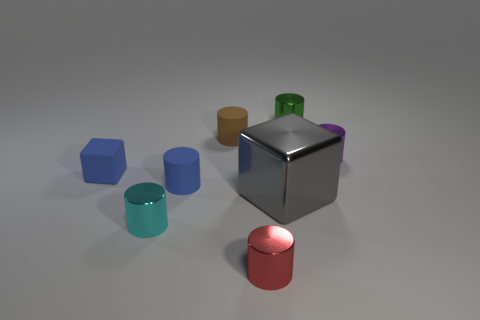Subtract all small brown rubber cylinders. How many cylinders are left? 5 Add 1 small cyan objects. How many objects exist? 9 Subtract all gray cubes. How many cubes are left? 1 Subtract 1 cubes. How many cubes are left? 1 Subtract 1 cyan cylinders. How many objects are left? 7 Subtract all cylinders. How many objects are left? 2 Subtract all yellow cylinders. Subtract all yellow cubes. How many cylinders are left? 6 Subtract all cyan balls. How many green cubes are left? 0 Subtract all small blue matte cylinders. Subtract all big gray cubes. How many objects are left? 6 Add 3 cylinders. How many cylinders are left? 9 